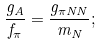Convert formula to latex. <formula><loc_0><loc_0><loc_500><loc_500>\frac { g _ { A } } { f _ { \pi } } = \frac { g _ { \pi N N } } { m _ { N } } ;</formula> 